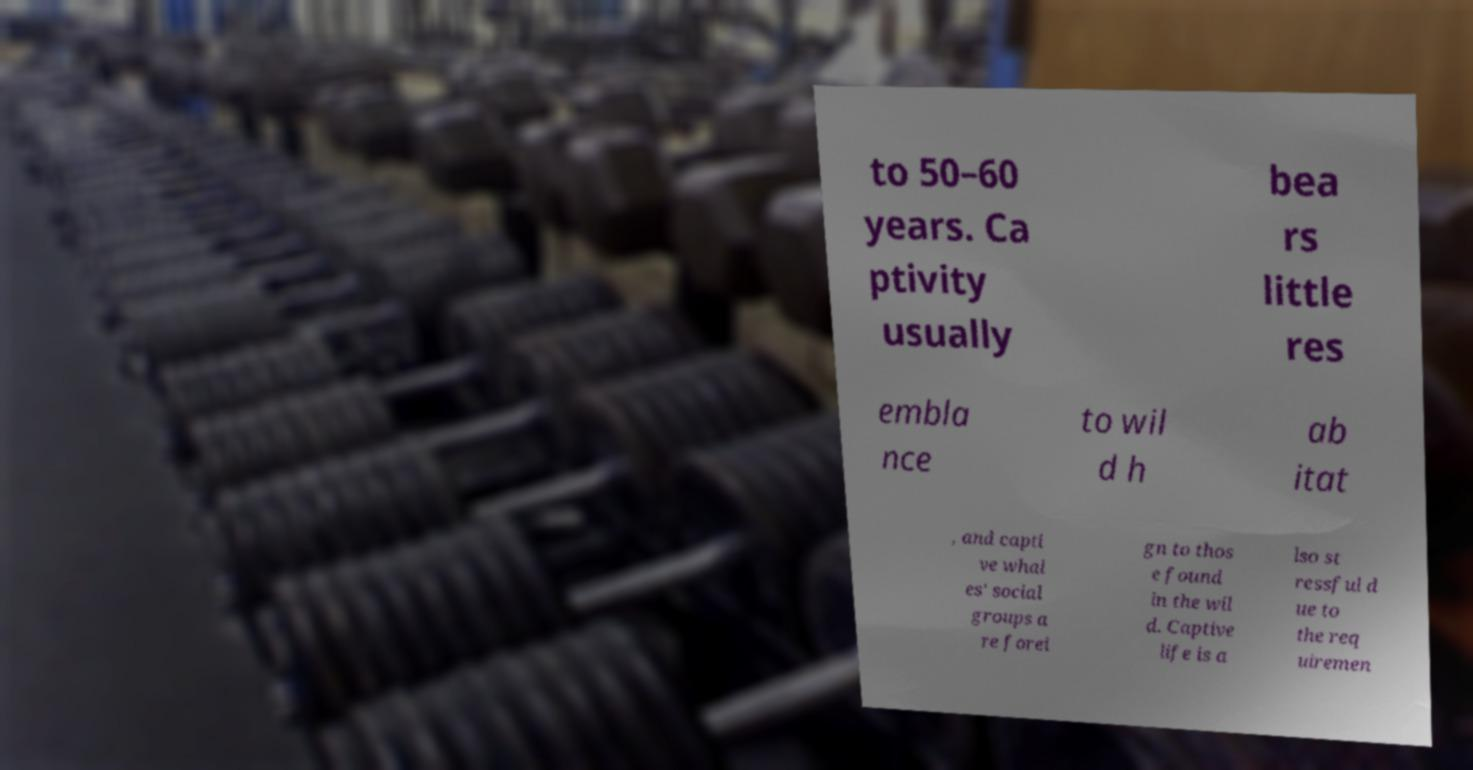There's text embedded in this image that I need extracted. Can you transcribe it verbatim? to 50–60 years. Ca ptivity usually bea rs little res embla nce to wil d h ab itat , and capti ve whal es' social groups a re forei gn to thos e found in the wil d. Captive life is a lso st ressful d ue to the req uiremen 